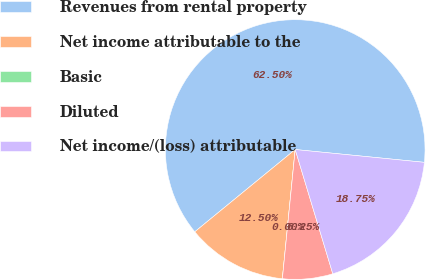Convert chart to OTSL. <chart><loc_0><loc_0><loc_500><loc_500><pie_chart><fcel>Revenues from rental property<fcel>Net income attributable to the<fcel>Basic<fcel>Diluted<fcel>Net income/(loss) attributable<nl><fcel>62.5%<fcel>12.5%<fcel>0.0%<fcel>6.25%<fcel>18.75%<nl></chart> 